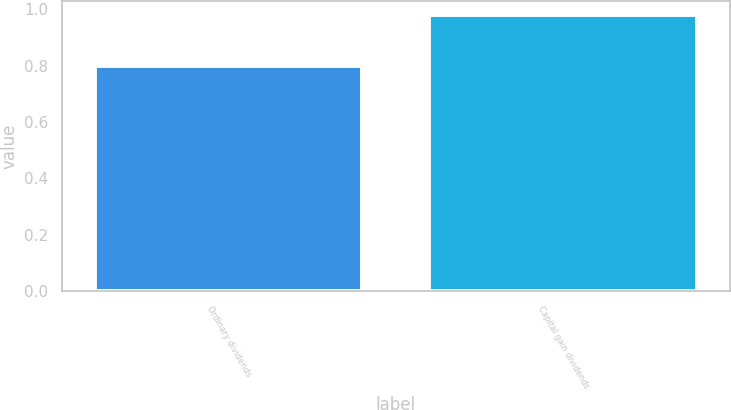<chart> <loc_0><loc_0><loc_500><loc_500><bar_chart><fcel>Ordinary dividends<fcel>Capital gain dividends<nl><fcel>0.8<fcel>0.98<nl></chart> 